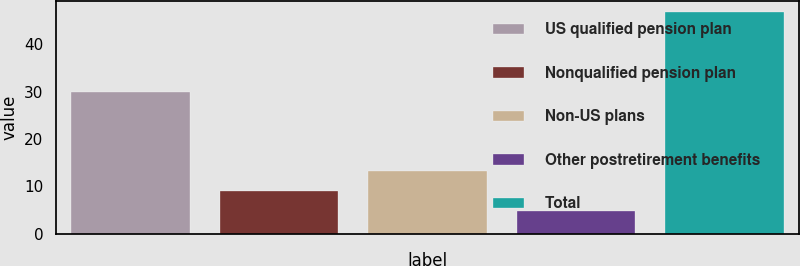Convert chart to OTSL. <chart><loc_0><loc_0><loc_500><loc_500><bar_chart><fcel>US qualified pension plan<fcel>Nonqualified pension plan<fcel>Non-US plans<fcel>Other postretirement benefits<fcel>Total<nl><fcel>30<fcel>8.91<fcel>13.12<fcel>4.7<fcel>46.8<nl></chart> 